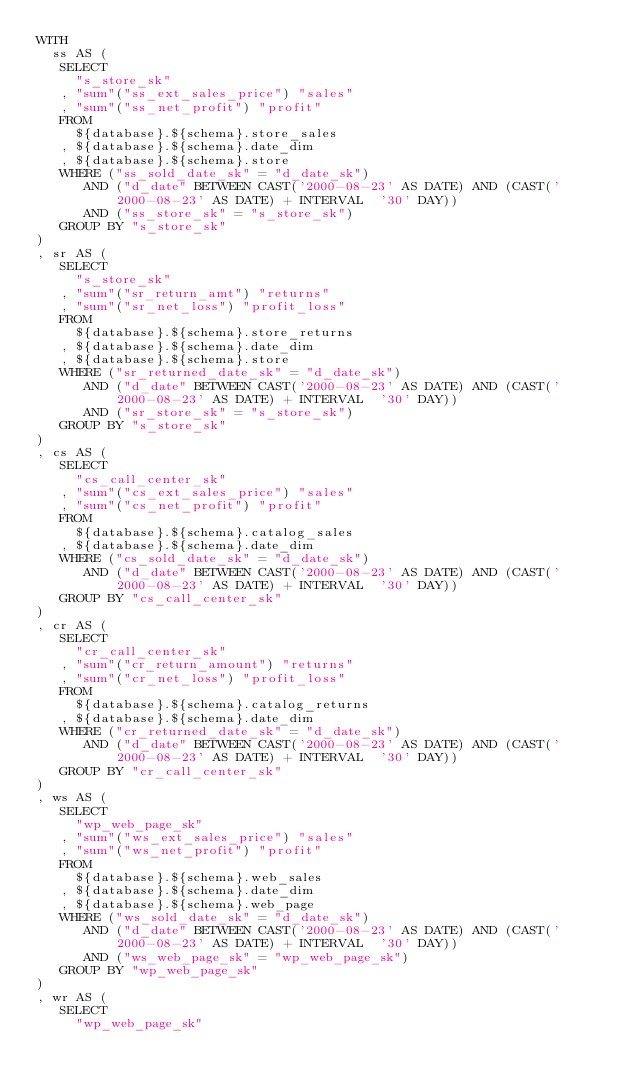<code> <loc_0><loc_0><loc_500><loc_500><_SQL_>WITH
  ss AS (
   SELECT
     "s_store_sk"
   , "sum"("ss_ext_sales_price") "sales"
   , "sum"("ss_net_profit") "profit"
   FROM
     ${database}.${schema}.store_sales
   , ${database}.${schema}.date_dim
   , ${database}.${schema}.store
   WHERE ("ss_sold_date_sk" = "d_date_sk")
      AND ("d_date" BETWEEN CAST('2000-08-23' AS DATE) AND (CAST('2000-08-23' AS DATE) + INTERVAL  '30' DAY))
      AND ("ss_store_sk" = "s_store_sk")
   GROUP BY "s_store_sk"
) 
, sr AS (
   SELECT
     "s_store_sk"
   , "sum"("sr_return_amt") "returns"
   , "sum"("sr_net_loss") "profit_loss"
   FROM
     ${database}.${schema}.store_returns
   , ${database}.${schema}.date_dim
   , ${database}.${schema}.store
   WHERE ("sr_returned_date_sk" = "d_date_sk")
      AND ("d_date" BETWEEN CAST('2000-08-23' AS DATE) AND (CAST('2000-08-23' AS DATE) + INTERVAL  '30' DAY))
      AND ("sr_store_sk" = "s_store_sk")
   GROUP BY "s_store_sk"
) 
, cs AS (
   SELECT
     "cs_call_center_sk"
   , "sum"("cs_ext_sales_price") "sales"
   , "sum"("cs_net_profit") "profit"
   FROM
     ${database}.${schema}.catalog_sales
   , ${database}.${schema}.date_dim
   WHERE ("cs_sold_date_sk" = "d_date_sk")
      AND ("d_date" BETWEEN CAST('2000-08-23' AS DATE) AND (CAST('2000-08-23' AS DATE) + INTERVAL  '30' DAY))
   GROUP BY "cs_call_center_sk"
) 
, cr AS (
   SELECT
     "cr_call_center_sk"
   , "sum"("cr_return_amount") "returns"
   , "sum"("cr_net_loss") "profit_loss"
   FROM
     ${database}.${schema}.catalog_returns
   , ${database}.${schema}.date_dim
   WHERE ("cr_returned_date_sk" = "d_date_sk")
      AND ("d_date" BETWEEN CAST('2000-08-23' AS DATE) AND (CAST('2000-08-23' AS DATE) + INTERVAL  '30' DAY))
   GROUP BY "cr_call_center_sk"
) 
, ws AS (
   SELECT
     "wp_web_page_sk"
   , "sum"("ws_ext_sales_price") "sales"
   , "sum"("ws_net_profit") "profit"
   FROM
     ${database}.${schema}.web_sales
   , ${database}.${schema}.date_dim
   , ${database}.${schema}.web_page
   WHERE ("ws_sold_date_sk" = "d_date_sk")
      AND ("d_date" BETWEEN CAST('2000-08-23' AS DATE) AND (CAST('2000-08-23' AS DATE) + INTERVAL  '30' DAY))
      AND ("ws_web_page_sk" = "wp_web_page_sk")
   GROUP BY "wp_web_page_sk"
) 
, wr AS (
   SELECT
     "wp_web_page_sk"</code> 